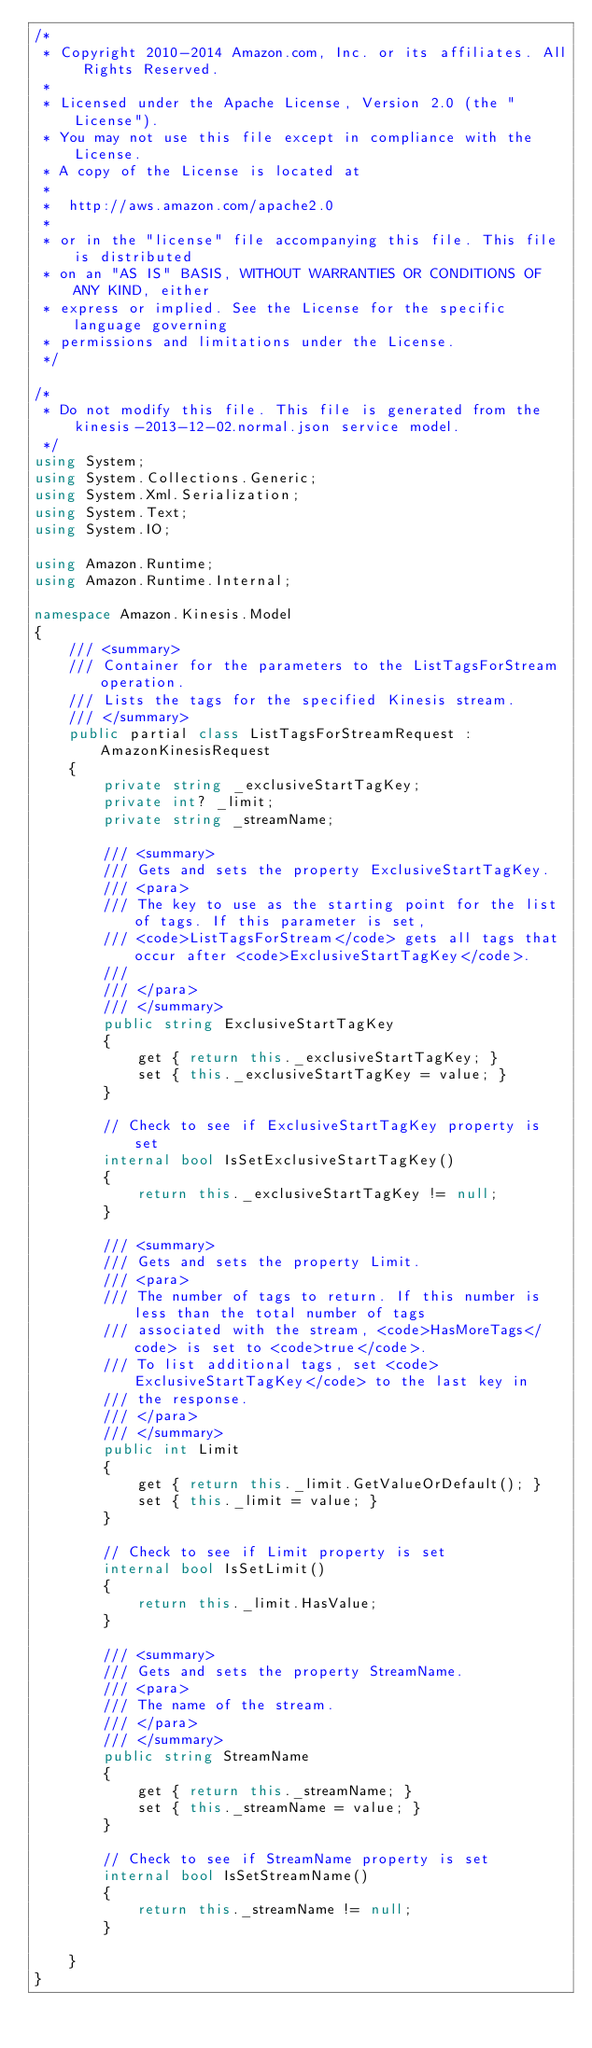Convert code to text. <code><loc_0><loc_0><loc_500><loc_500><_C#_>/*
 * Copyright 2010-2014 Amazon.com, Inc. or its affiliates. All Rights Reserved.
 * 
 * Licensed under the Apache License, Version 2.0 (the "License").
 * You may not use this file except in compliance with the License.
 * A copy of the License is located at
 * 
 *  http://aws.amazon.com/apache2.0
 * 
 * or in the "license" file accompanying this file. This file is distributed
 * on an "AS IS" BASIS, WITHOUT WARRANTIES OR CONDITIONS OF ANY KIND, either
 * express or implied. See the License for the specific language governing
 * permissions and limitations under the License.
 */

/*
 * Do not modify this file. This file is generated from the kinesis-2013-12-02.normal.json service model.
 */
using System;
using System.Collections.Generic;
using System.Xml.Serialization;
using System.Text;
using System.IO;

using Amazon.Runtime;
using Amazon.Runtime.Internal;

namespace Amazon.Kinesis.Model
{
    /// <summary>
    /// Container for the parameters to the ListTagsForStream operation.
    /// Lists the tags for the specified Kinesis stream.
    /// </summary>
    public partial class ListTagsForStreamRequest : AmazonKinesisRequest
    {
        private string _exclusiveStartTagKey;
        private int? _limit;
        private string _streamName;

        /// <summary>
        /// Gets and sets the property ExclusiveStartTagKey. 
        /// <para>
        /// The key to use as the starting point for the list of tags. If this parameter is set,
        /// <code>ListTagsForStream</code> gets all tags that occur after <code>ExclusiveStartTagKey</code>.
        /// 
        /// </para>
        /// </summary>
        public string ExclusiveStartTagKey
        {
            get { return this._exclusiveStartTagKey; }
            set { this._exclusiveStartTagKey = value; }
        }

        // Check to see if ExclusiveStartTagKey property is set
        internal bool IsSetExclusiveStartTagKey()
        {
            return this._exclusiveStartTagKey != null;
        }

        /// <summary>
        /// Gets and sets the property Limit. 
        /// <para>
        /// The number of tags to return. If this number is less than the total number of tags
        /// associated with the stream, <code>HasMoreTags</code> is set to <code>true</code>.
        /// To list additional tags, set <code>ExclusiveStartTagKey</code> to the last key in
        /// the response.
        /// </para>
        /// </summary>
        public int Limit
        {
            get { return this._limit.GetValueOrDefault(); }
            set { this._limit = value; }
        }

        // Check to see if Limit property is set
        internal bool IsSetLimit()
        {
            return this._limit.HasValue; 
        }

        /// <summary>
        /// Gets and sets the property StreamName. 
        /// <para>
        /// The name of the stream.
        /// </para>
        /// </summary>
        public string StreamName
        {
            get { return this._streamName; }
            set { this._streamName = value; }
        }

        // Check to see if StreamName property is set
        internal bool IsSetStreamName()
        {
            return this._streamName != null;
        }

    }
}</code> 